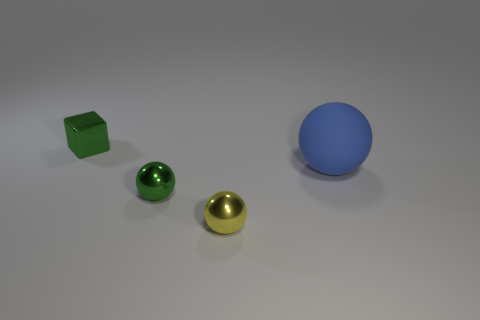Which object in the image appears the smoothest and most reflective? The golden sphere looks to be the smoothest and most reflective object in the image, given its high sheen and clear light reflections. 